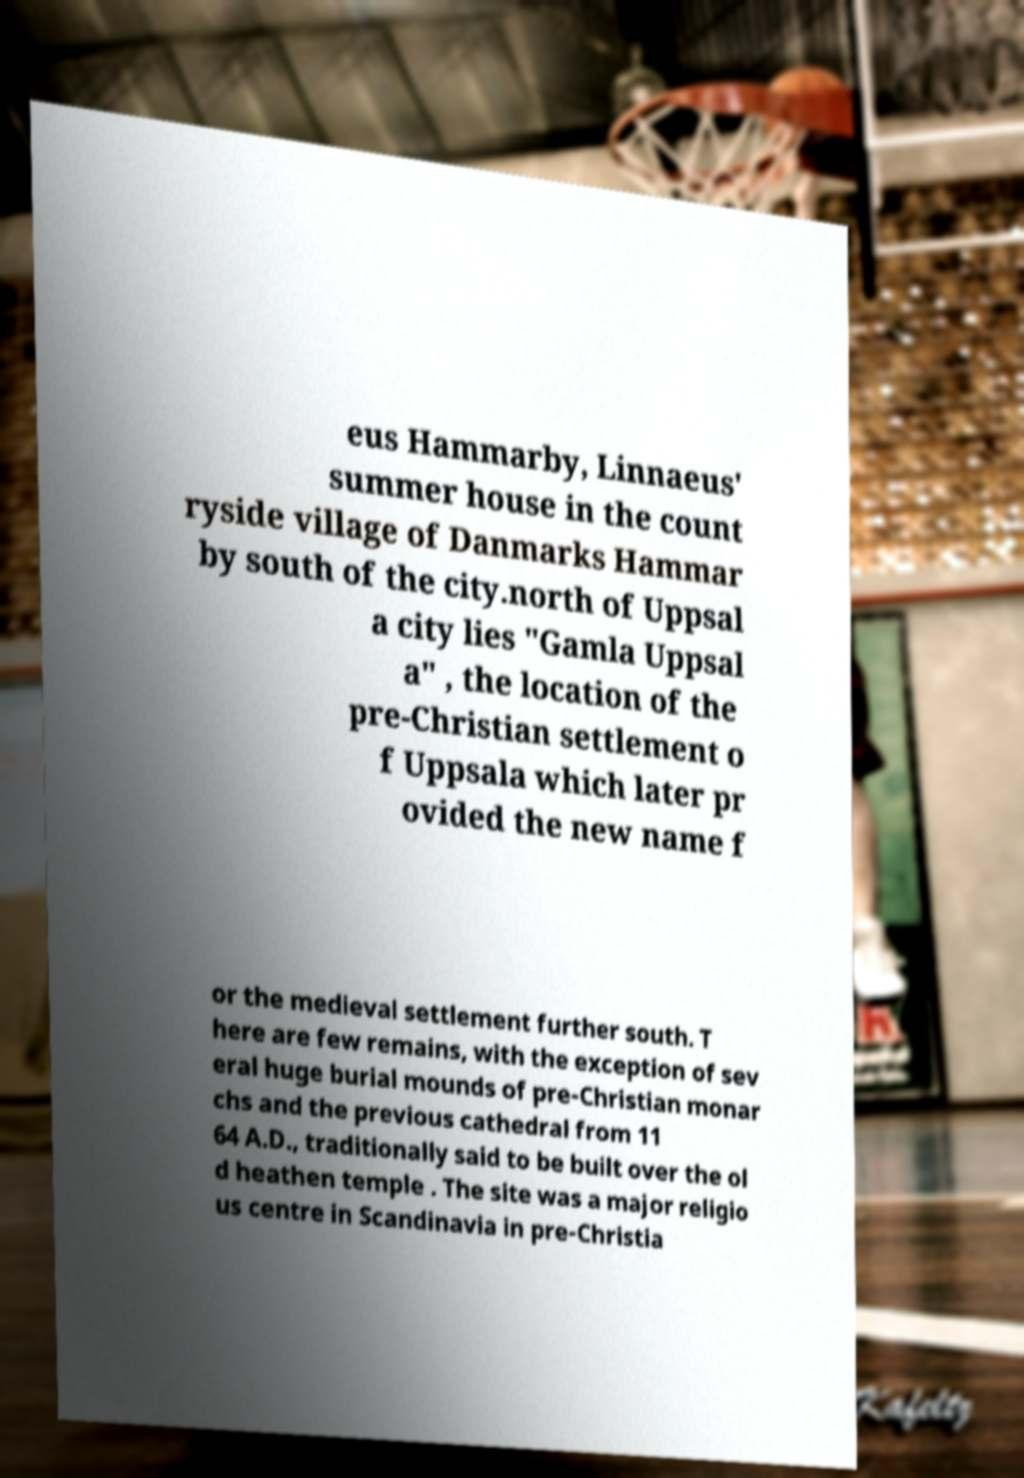For documentation purposes, I need the text within this image transcribed. Could you provide that? eus Hammarby, Linnaeus' summer house in the count ryside village of Danmarks Hammar by south of the city.north of Uppsal a city lies "Gamla Uppsal a" , the location of the pre-Christian settlement o f Uppsala which later pr ovided the new name f or the medieval settlement further south. T here are few remains, with the exception of sev eral huge burial mounds of pre-Christian monar chs and the previous cathedral from 11 64 A.D., traditionally said to be built over the ol d heathen temple . The site was a major religio us centre in Scandinavia in pre-Christia 